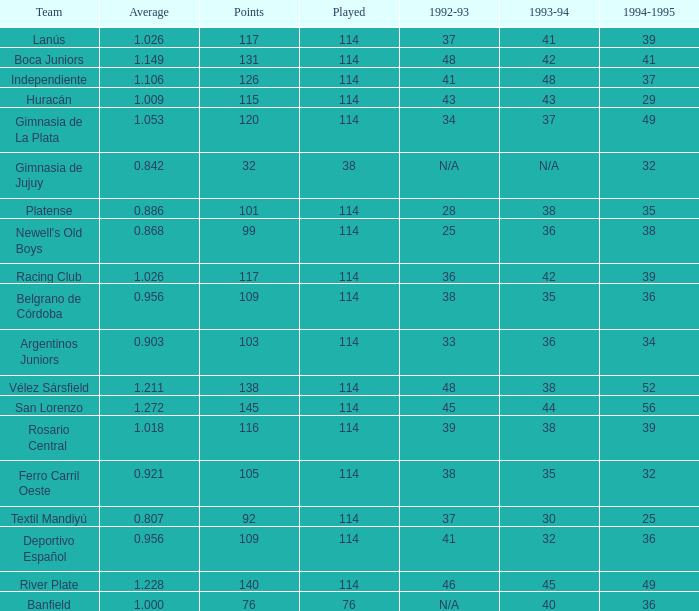Name the most played 114.0. 